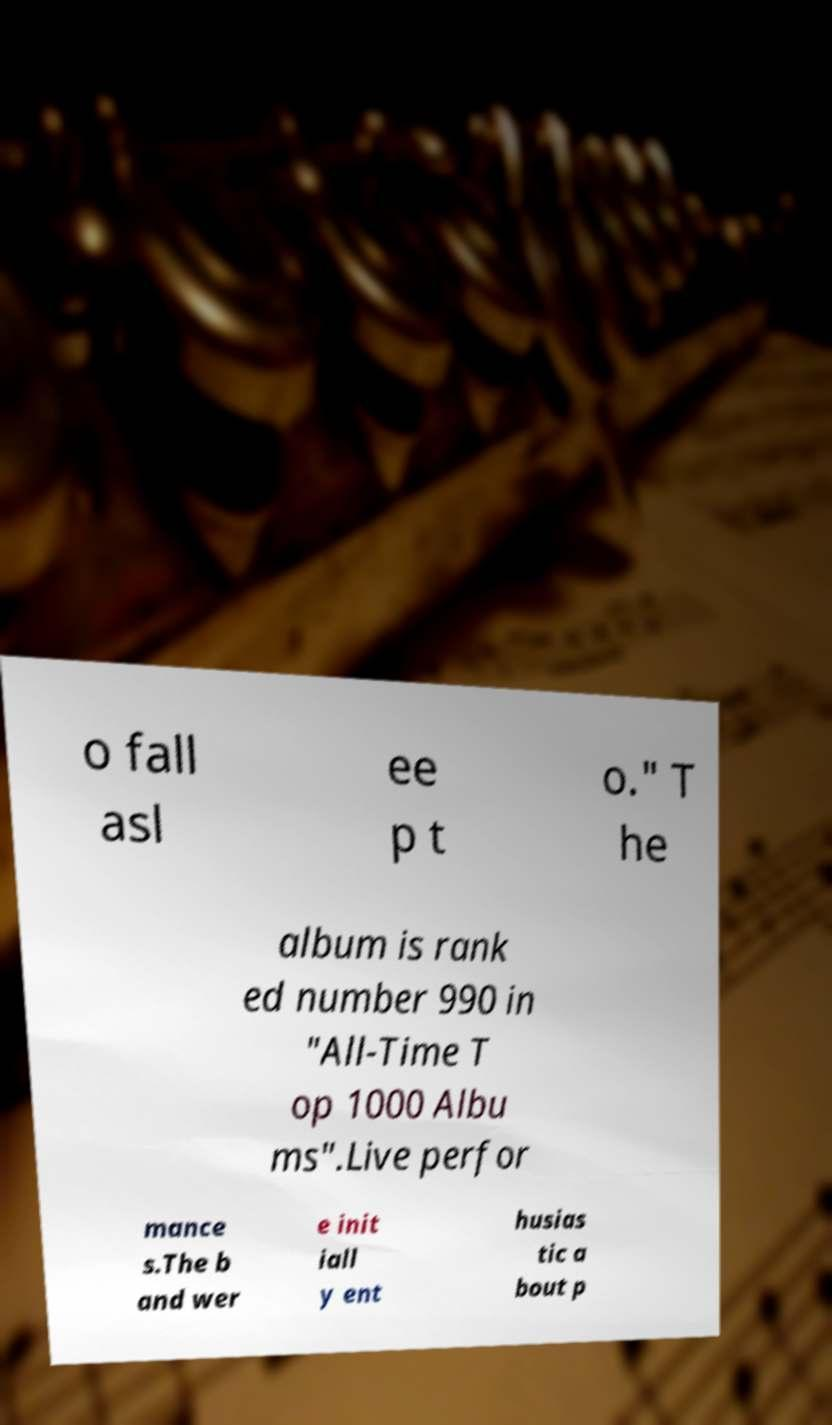Could you assist in decoding the text presented in this image and type it out clearly? o fall asl ee p t o." T he album is rank ed number 990 in "All-Time T op 1000 Albu ms".Live perfor mance s.The b and wer e init iall y ent husias tic a bout p 